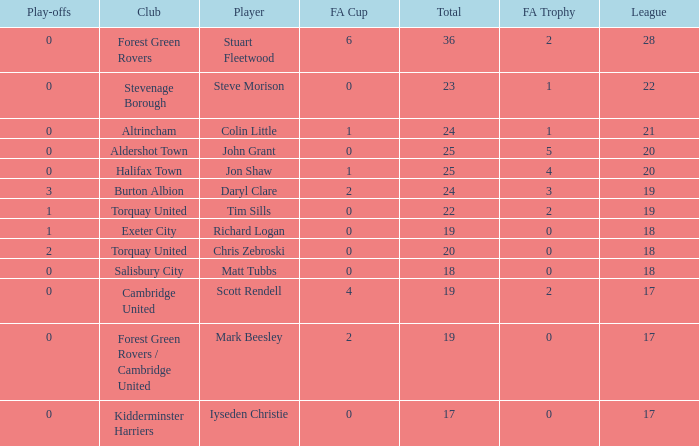What mean total had a league number of 18, Richard Logan as a player, and a play-offs number smaller than 1? None. 